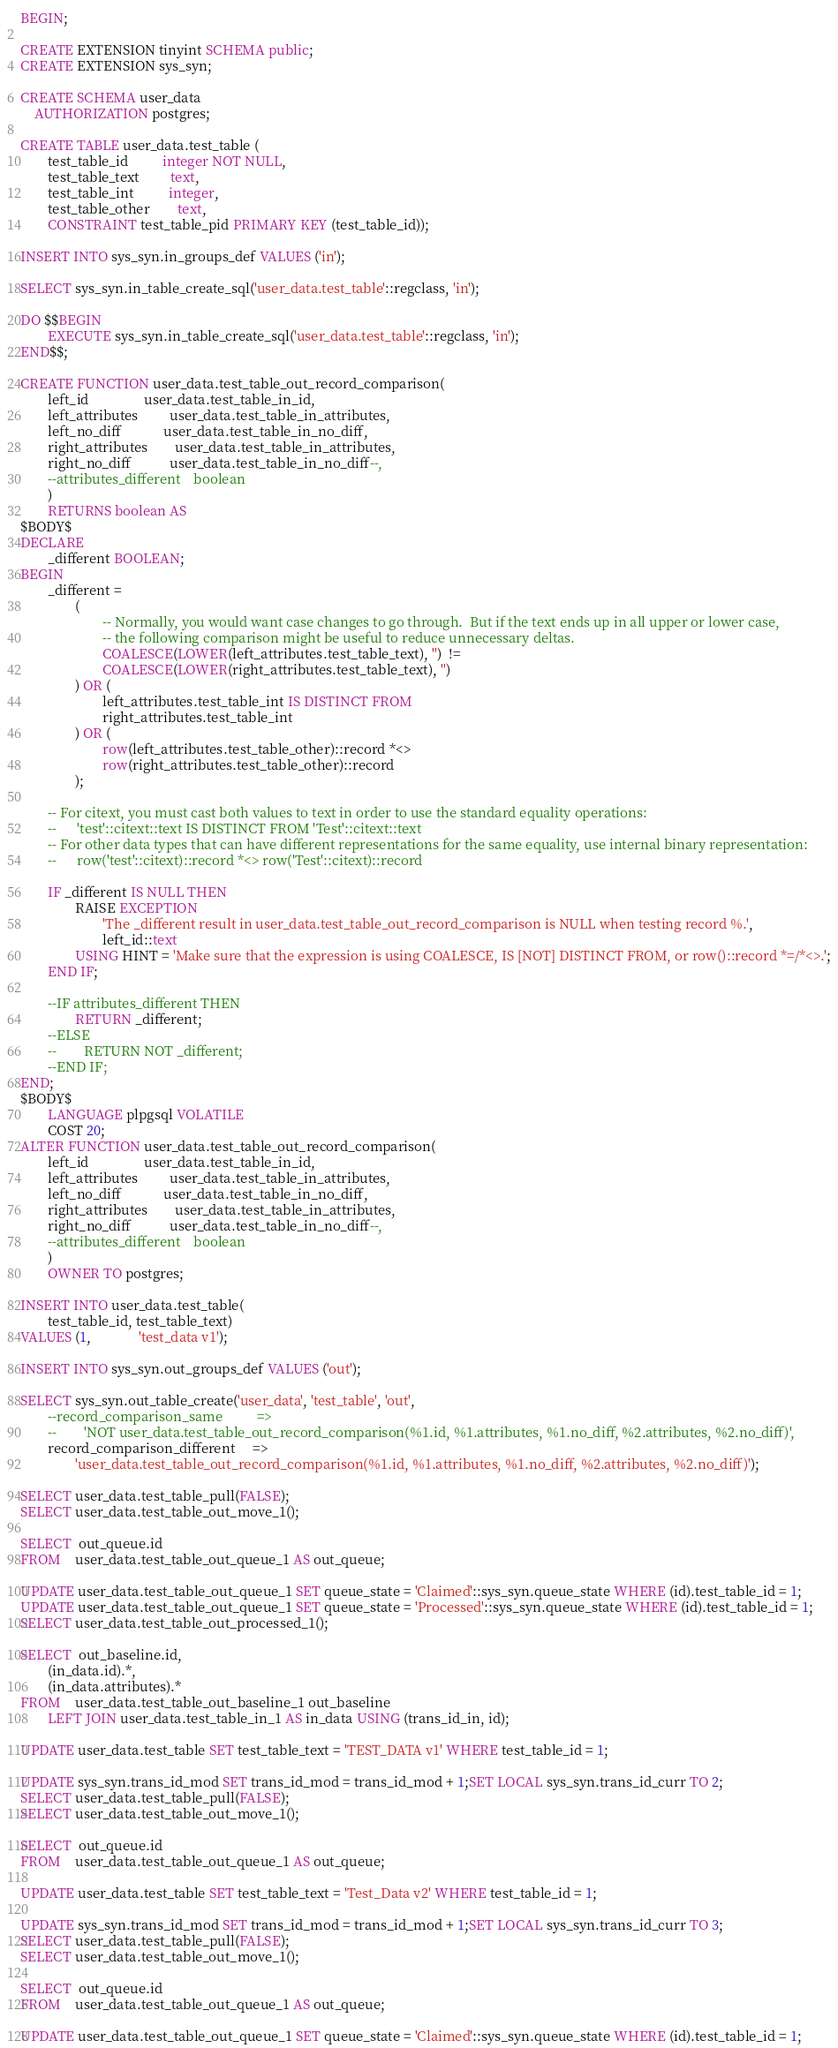Convert code to text. <code><loc_0><loc_0><loc_500><loc_500><_SQL_>BEGIN;

CREATE EXTENSION tinyint SCHEMA public;
CREATE EXTENSION sys_syn;

CREATE SCHEMA user_data
    AUTHORIZATION postgres;

CREATE TABLE user_data.test_table (
        test_table_id          integer NOT NULL,
        test_table_text         text,
        test_table_int          integer,
        test_table_other        text,
        CONSTRAINT test_table_pid PRIMARY KEY (test_table_id));

INSERT INTO sys_syn.in_groups_def VALUES ('in');

SELECT sys_syn.in_table_create_sql('user_data.test_table'::regclass, 'in');

DO $$BEGIN
        EXECUTE sys_syn.in_table_create_sql('user_data.test_table'::regclass, 'in');
END$$;

CREATE FUNCTION user_data.test_table_out_record_comparison(
        left_id                user_data.test_table_in_id,
        left_attributes         user_data.test_table_in_attributes,
        left_no_diff            user_data.test_table_in_no_diff,
        right_attributes        user_data.test_table_in_attributes,
        right_no_diff           user_data.test_table_in_no_diff--,
        --attributes_different    boolean
        )
        RETURNS boolean AS
$BODY$
DECLARE
        _different BOOLEAN;
BEGIN
        _different =
                (
                        -- Normally, you would want case changes to go through.  But if the text ends up in all upper or lower case,
                        -- the following comparison might be useful to reduce unnecessary deltas.
                        COALESCE(LOWER(left_attributes.test_table_text), '')  !=
                        COALESCE(LOWER(right_attributes.test_table_text), '')
                ) OR (
                        left_attributes.test_table_int IS DISTINCT FROM
                        right_attributes.test_table_int
                ) OR (
                        row(left_attributes.test_table_other)::record *<>
                        row(right_attributes.test_table_other)::record
                );

        -- For citext, you must cast both values to text in order to use the standard equality operations:
        --      'test'::citext::text IS DISTINCT FROM 'Test'::citext::text
        -- For other data types that can have different representations for the same equality, use internal binary representation:
        --      row('test'::citext)::record *<> row('Test'::citext)::record

        IF _different IS NULL THEN
                RAISE EXCEPTION
                        'The _different result in user_data.test_table_out_record_comparison is NULL when testing record %.',
                        left_id::text
                USING HINT = 'Make sure that the expression is using COALESCE, IS [NOT] DISTINCT FROM, or row()::record *=/*<>.';
        END IF;

        --IF attributes_different THEN
                RETURN _different;
        --ELSE
        --        RETURN NOT _different;
        --END IF;
END;
$BODY$
        LANGUAGE plpgsql VOLATILE
        COST 20;
ALTER FUNCTION user_data.test_table_out_record_comparison(
        left_id                user_data.test_table_in_id,
        left_attributes         user_data.test_table_in_attributes,
        left_no_diff            user_data.test_table_in_no_diff,
        right_attributes        user_data.test_table_in_attributes,
        right_no_diff           user_data.test_table_in_no_diff--,
        --attributes_different    boolean
        )
        OWNER TO postgres;

INSERT INTO user_data.test_table(
        test_table_id, test_table_text)
VALUES (1,              'test_data v1');

INSERT INTO sys_syn.out_groups_def VALUES ('out');

SELECT sys_syn.out_table_create('user_data', 'test_table', 'out',
        --record_comparison_same          =>
        --        'NOT user_data.test_table_out_record_comparison(%1.id, %1.attributes, %1.no_diff, %2.attributes, %2.no_diff)',
        record_comparison_different     =>
                'user_data.test_table_out_record_comparison(%1.id, %1.attributes, %1.no_diff, %2.attributes, %2.no_diff)');

SELECT user_data.test_table_pull(FALSE);
SELECT user_data.test_table_out_move_1();

SELECT  out_queue.id
FROM    user_data.test_table_out_queue_1 AS out_queue;

UPDATE user_data.test_table_out_queue_1 SET queue_state = 'Claimed'::sys_syn.queue_state WHERE (id).test_table_id = 1;
UPDATE user_data.test_table_out_queue_1 SET queue_state = 'Processed'::sys_syn.queue_state WHERE (id).test_table_id = 1;
SELECT user_data.test_table_out_processed_1();

SELECT  out_baseline.id,
        (in_data.id).*,
        (in_data.attributes).*
FROM    user_data.test_table_out_baseline_1 out_baseline
        LEFT JOIN user_data.test_table_in_1 AS in_data USING (trans_id_in, id);

UPDATE user_data.test_table SET test_table_text = 'TEST_DATA v1' WHERE test_table_id = 1;

UPDATE sys_syn.trans_id_mod SET trans_id_mod = trans_id_mod + 1;SET LOCAL sys_syn.trans_id_curr TO 2;
SELECT user_data.test_table_pull(FALSE);
SELECT user_data.test_table_out_move_1();

SELECT  out_queue.id
FROM    user_data.test_table_out_queue_1 AS out_queue;

UPDATE user_data.test_table SET test_table_text = 'Test_Data v2' WHERE test_table_id = 1;

UPDATE sys_syn.trans_id_mod SET trans_id_mod = trans_id_mod + 1;SET LOCAL sys_syn.trans_id_curr TO 3;
SELECT user_data.test_table_pull(FALSE);
SELECT user_data.test_table_out_move_1();

SELECT  out_queue.id
FROM    user_data.test_table_out_queue_1 AS out_queue;

UPDATE user_data.test_table_out_queue_1 SET queue_state = 'Claimed'::sys_syn.queue_state WHERE (id).test_table_id = 1;</code> 